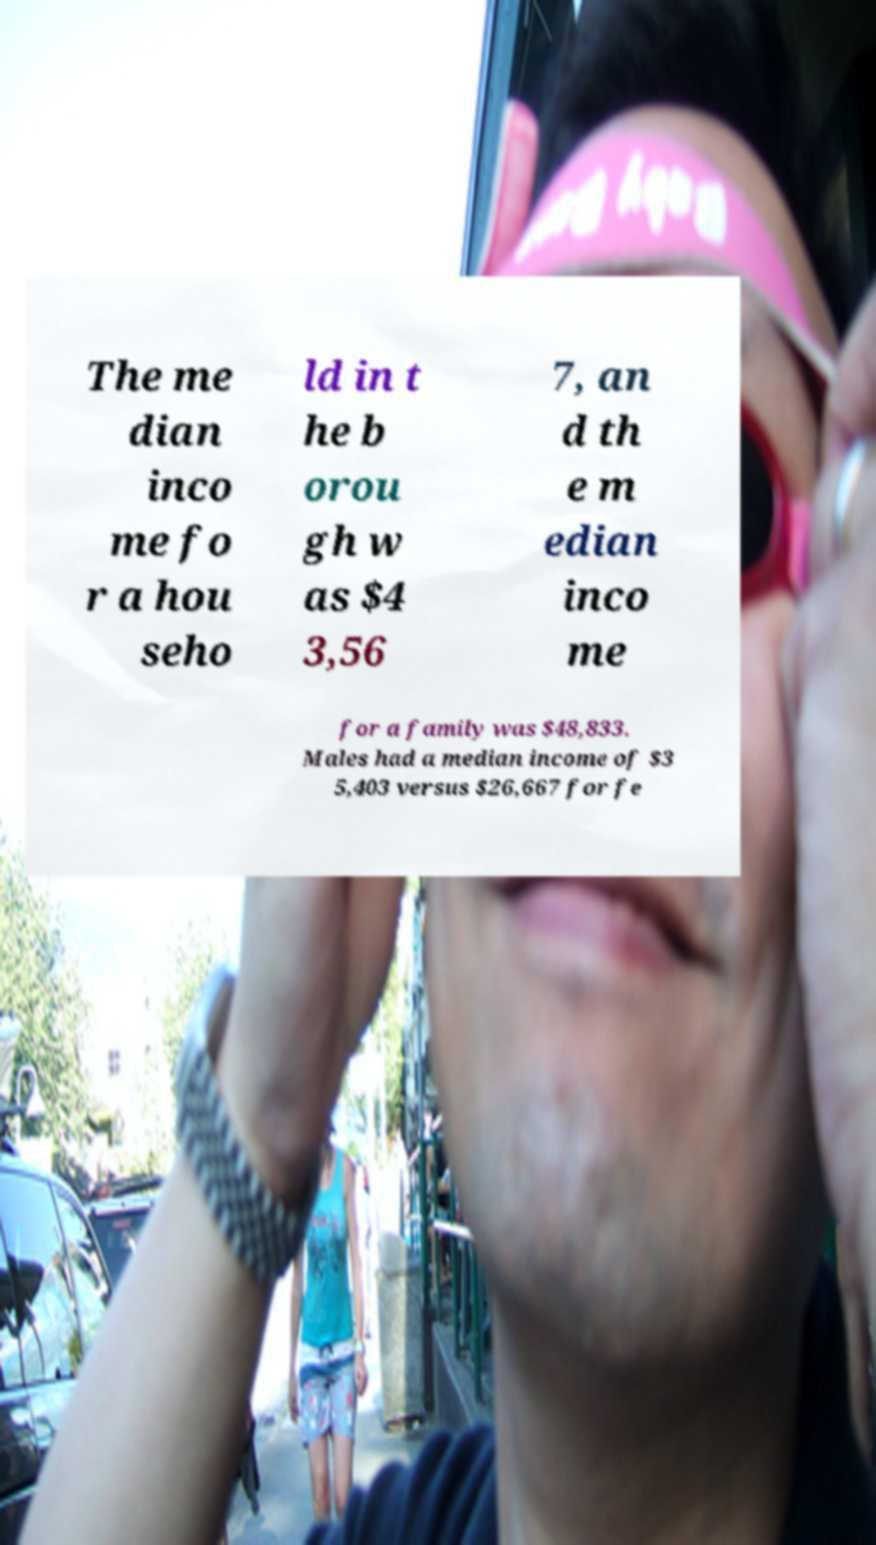Please read and relay the text visible in this image. What does it say? The me dian inco me fo r a hou seho ld in t he b orou gh w as $4 3,56 7, an d th e m edian inco me for a family was $48,833. Males had a median income of $3 5,403 versus $26,667 for fe 